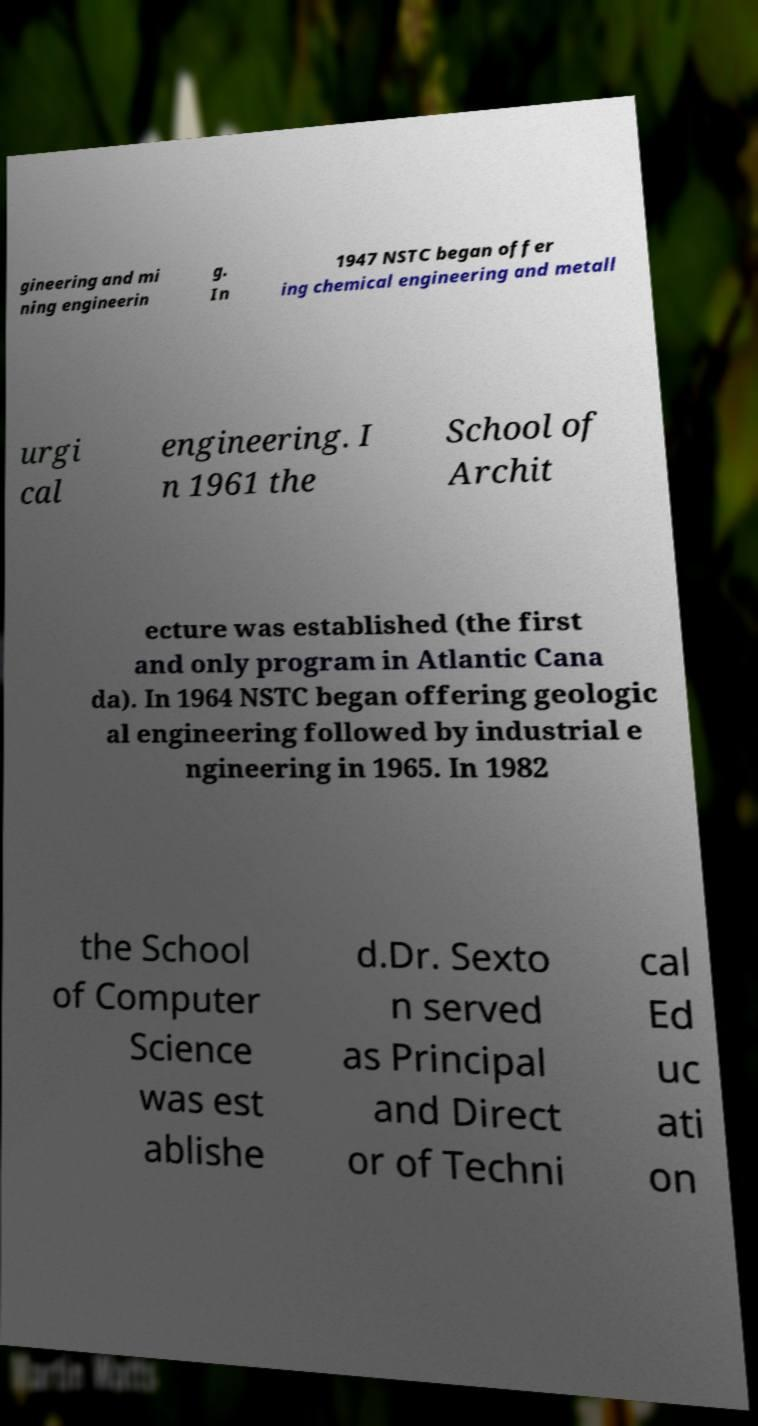Could you assist in decoding the text presented in this image and type it out clearly? gineering and mi ning engineerin g. In 1947 NSTC began offer ing chemical engineering and metall urgi cal engineering. I n 1961 the School of Archit ecture was established (the first and only program in Atlantic Cana da). In 1964 NSTC began offering geologic al engineering followed by industrial e ngineering in 1965. In 1982 the School of Computer Science was est ablishe d.Dr. Sexto n served as Principal and Direct or of Techni cal Ed uc ati on 